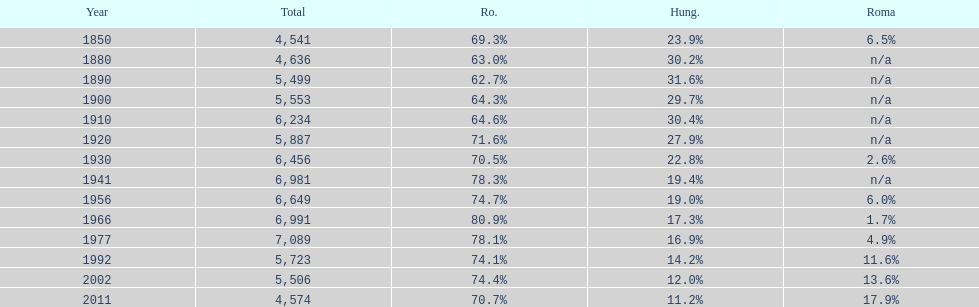What year had the next highest percentage for roma after 2011? 2002. 